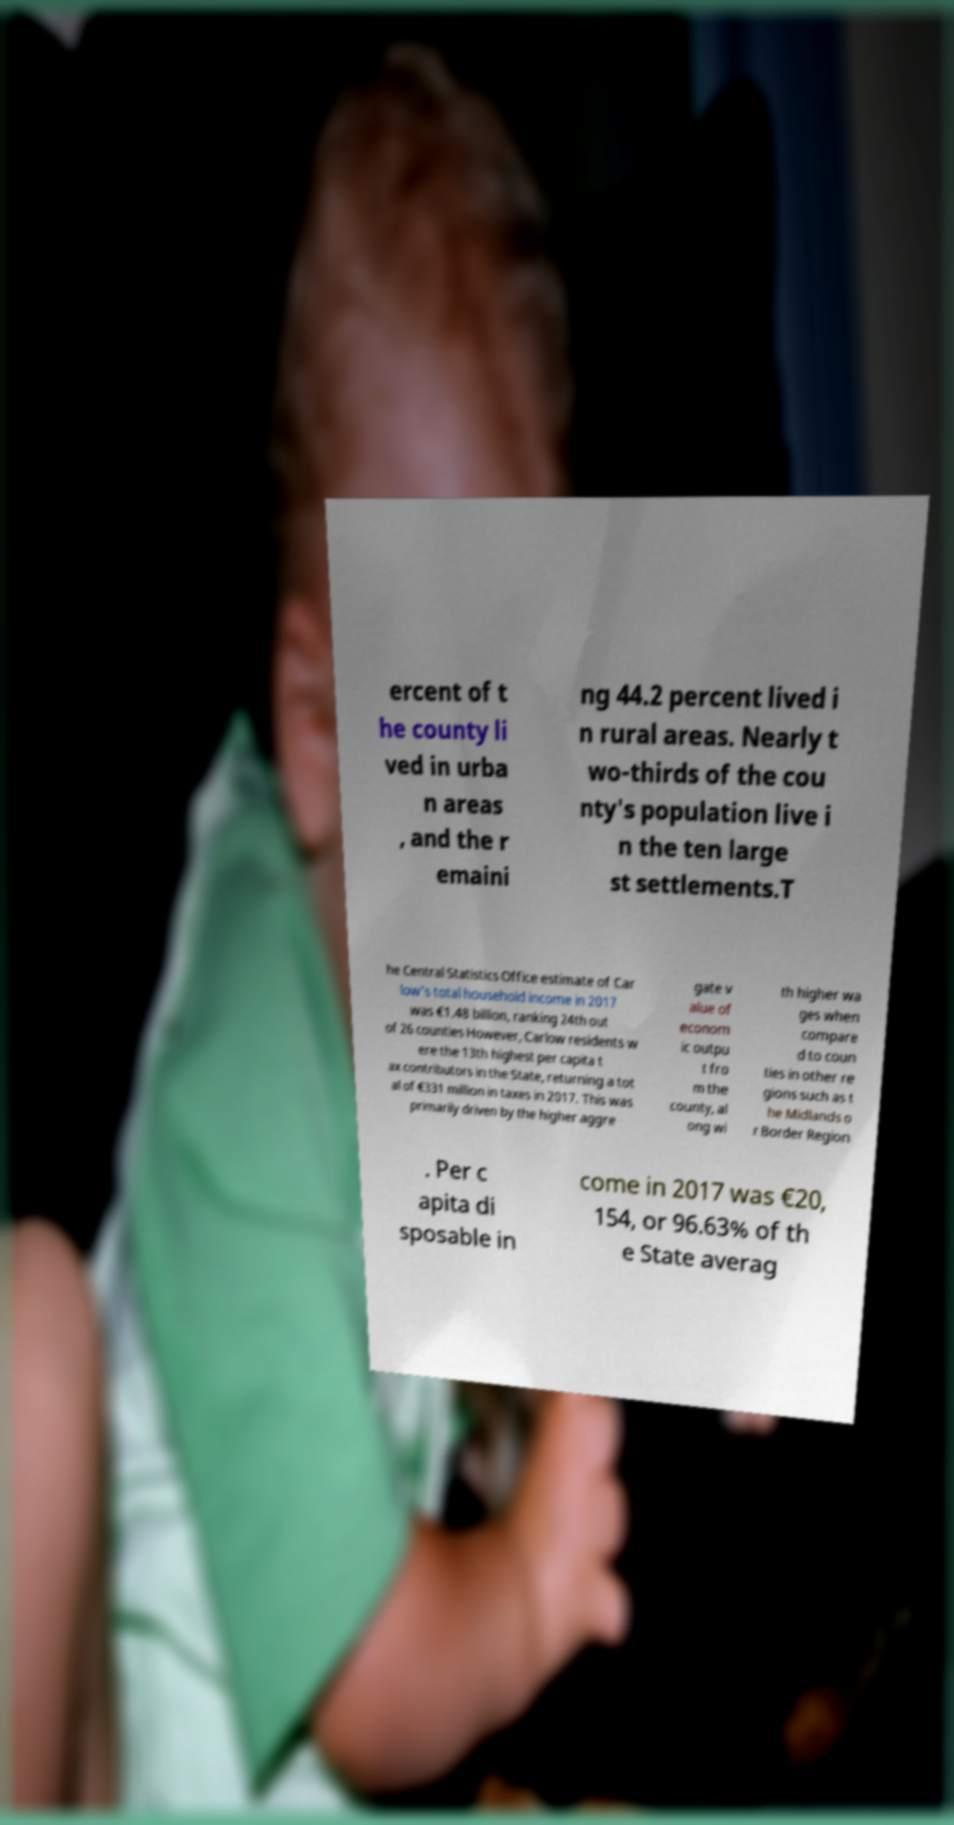Please read and relay the text visible in this image. What does it say? ercent of t he county li ved in urba n areas , and the r emaini ng 44.2 percent lived i n rural areas. Nearly t wo-thirds of the cou nty's population live i n the ten large st settlements.T he Central Statistics Office estimate of Car low's total household income in 2017 was €1.48 billion, ranking 24th out of 26 counties However, Carlow residents w ere the 13th highest per capita t ax contributors in the State, returning a tot al of €331 million in taxes in 2017. This was primarily driven by the higher aggre gate v alue of econom ic outpu t fro m the county, al ong wi th higher wa ges when compare d to coun ties in other re gions such as t he Midlands o r Border Region . Per c apita di sposable in come in 2017 was €20, 154, or 96.63% of th e State averag 